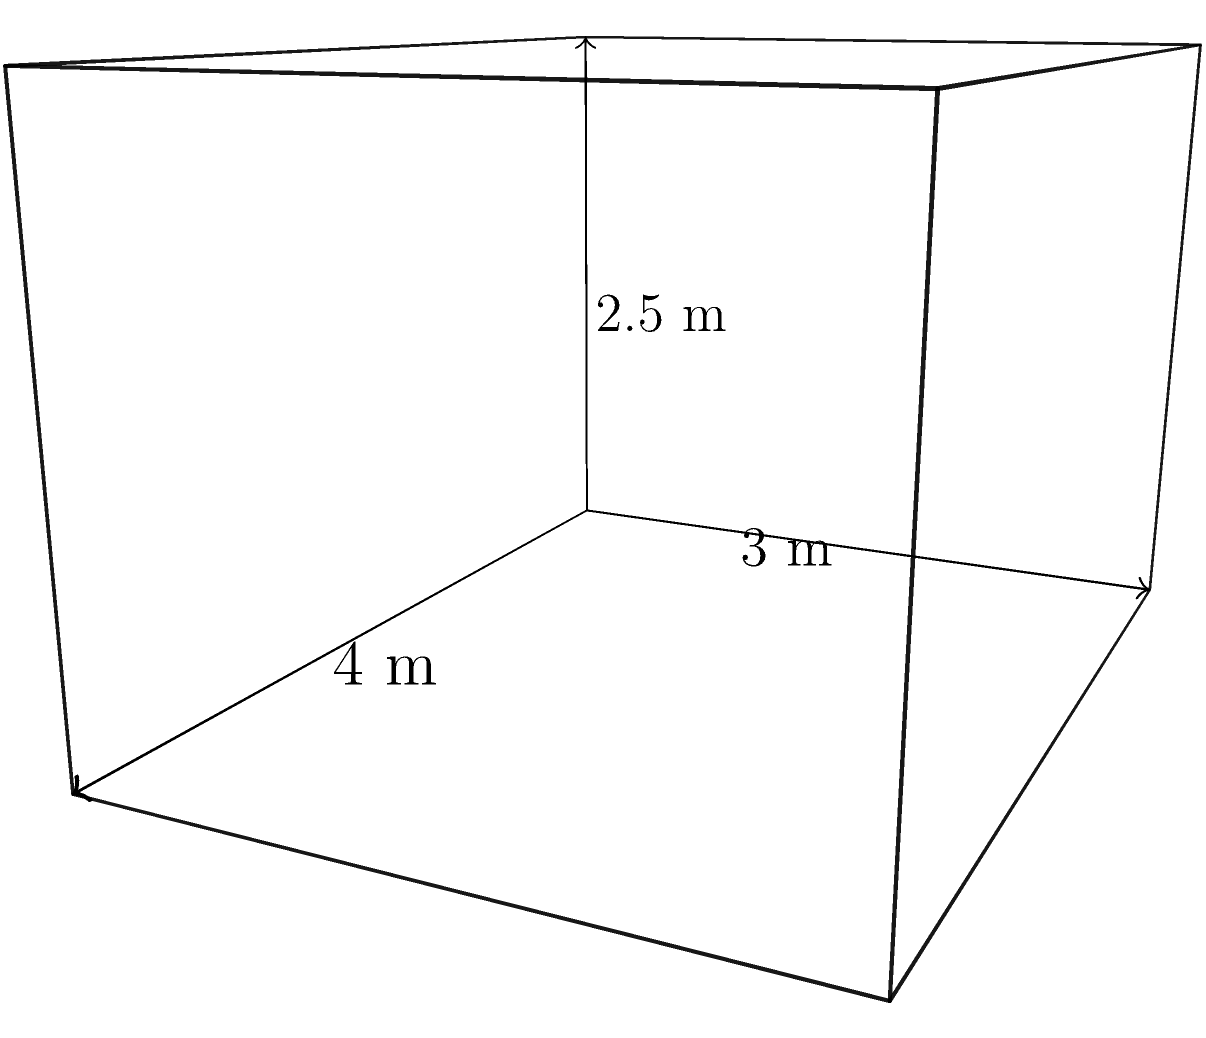A standard prison cell has dimensions of 4 meters in length, 3 meters in width, and 2.5 meters in height. Calculate the volume of this cell in cubic meters. How does this confined space contribute to the punishment aspect of incarceration? To calculate the volume of the prison cell, we need to multiply its length, width, and height.

Step 1: Identify the dimensions
Length (l) = 4 meters
Width (w) = 3 meters
Height (h) = 2.5 meters

Step 2: Apply the formula for the volume of a rectangular prism
$$V = l \times w \times h$$

Step 3: Substitute the values and calculate
$$V = 4 \text{ m} \times 3 \text{ m} \times 2.5 \text{ m}$$
$$V = 30 \text{ m}^3$$

The confined space of 30 cubic meters contributes to the punishment aspect of incarceration by:
1. Limiting physical movement and personal space
2. Creating a sense of isolation and confinement
3. Serving as a constant reminder of the loss of freedom
4. Potentially causing psychological discomfort due to the cramped environment

This restricted living area is part of the punitive measures designed to deter future criminal behavior and serve as retribution for the crimes committed.
Answer: 30 m³ 